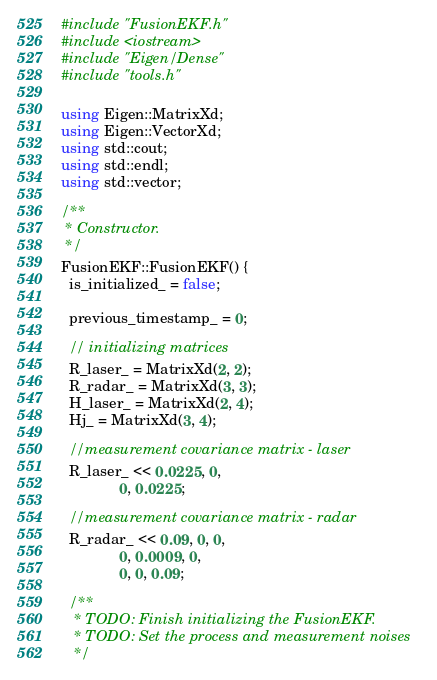<code> <loc_0><loc_0><loc_500><loc_500><_C++_>#include "FusionEKF.h"
#include <iostream>
#include "Eigen/Dense"
#include "tools.h"

using Eigen::MatrixXd;
using Eigen::VectorXd;
using std::cout;
using std::endl;
using std::vector;

/**
 * Constructor.
 */
FusionEKF::FusionEKF() {
  is_initialized_ = false;

  previous_timestamp_ = 0;

  // initializing matrices
  R_laser_ = MatrixXd(2, 2);
  R_radar_ = MatrixXd(3, 3);
  H_laser_ = MatrixXd(2, 4);
  Hj_ = MatrixXd(3, 4);

  //measurement covariance matrix - laser
  R_laser_ << 0.0225, 0,
              0, 0.0225;

  //measurement covariance matrix - radar
  R_radar_ << 0.09, 0, 0,
              0, 0.0009, 0,
              0, 0, 0.09;

  /**
   * TODO: Finish initializing the FusionEKF.
   * TODO: Set the process and measurement noises
   */
</code> 